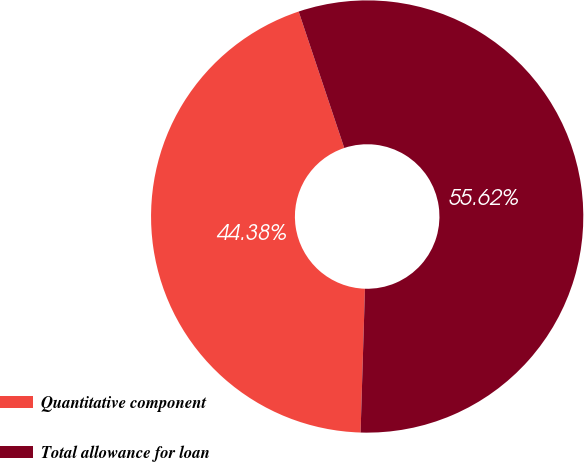Convert chart to OTSL. <chart><loc_0><loc_0><loc_500><loc_500><pie_chart><fcel>Quantitative component<fcel>Total allowance for loan<nl><fcel>44.38%<fcel>55.62%<nl></chart> 